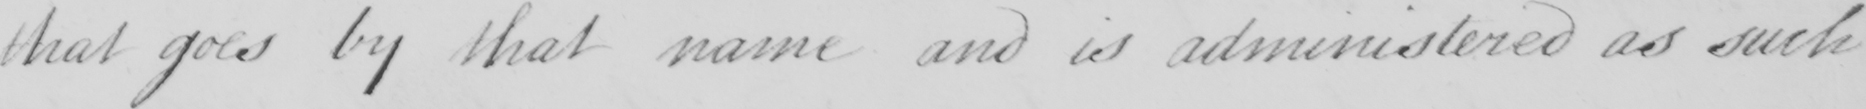Transcribe the text shown in this historical manuscript line. that goes by that name and is administered as such 